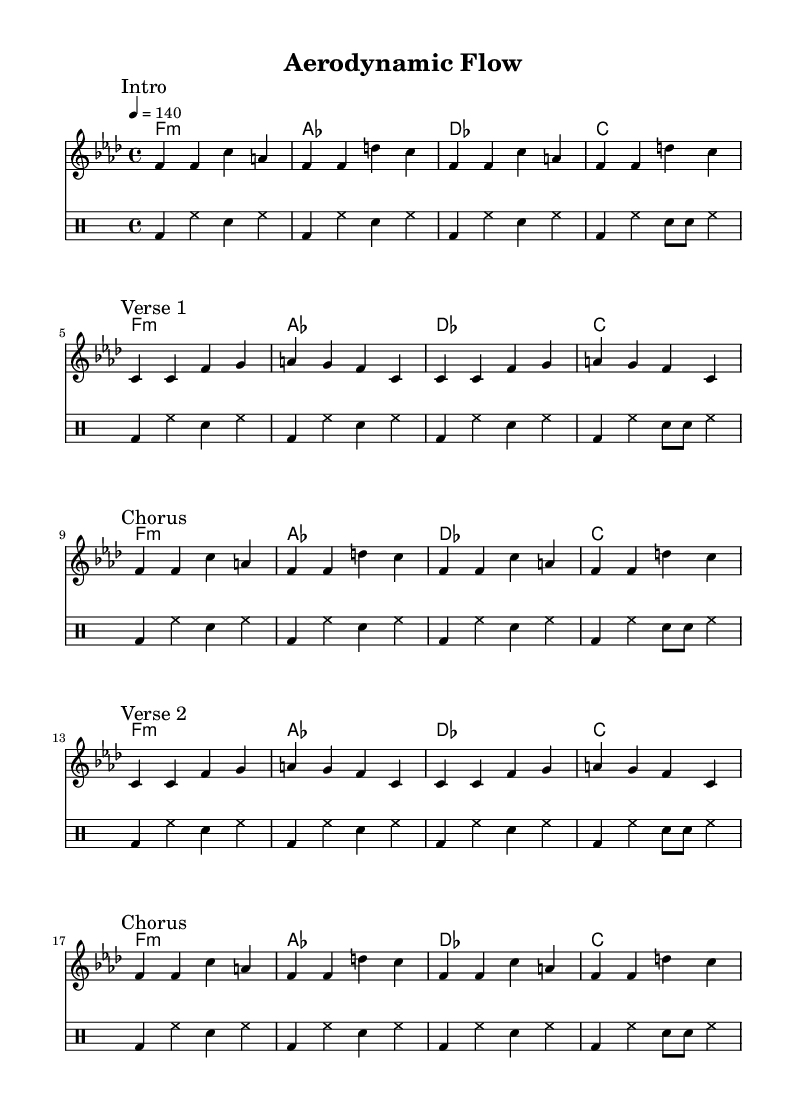What is the key signature of this music? The key signature is indicated at the beginning of the piece. It shows that there are four flats in the key signature, which corresponds to F minor.
Answer: F minor What is the time signature of this piece? The time signature is found at the beginning of the sheet music, which indicates the number of beats in each measure. It shows that there are four beats per measure, represented as 4/4.
Answer: 4/4 What tempo is indicated for the piece? The tempo marking indicates the speed of the piece. Here, it is set at 140 beats per minute, which is shown as "4 = 140."
Answer: 140 How many times is the main hook repeated in the melody? To find the repetition of the main hook, look for the sections labeled in the music. The main hook appears twice before the first break and twice again before the first chorus, making a total of four repetitions.
Answer: 4 What instrument is indicated for the chord names? The score contains a section labeled "ChordNames." This indicates that the chords are played on a harmonic instrument, typically used for accompaniment.
Answer: ChordNames Why is the verse pattern significant in this rap track? The verse pattern establishes a lyrical basis vital to rap. Analyzing the repeated arrangements in the melody highlights the song's rhythm and flow, showing how they support the delivery of lyrics. The repetitive structure in verse patterns is essential for creating a dynamic rap experience, maintaining listener engagement.
Answer: Verses How does the drum part contribute to the energy of the rap track? The drum part is written in a distinct rhythmic pattern that features bass drums, hi-hats, and snare drums. Analyzing the consistent beat and syncopation creates a driving rhythm that elevates the energy, supporting the high-speed racing theme effectively in the context of the rap.
Answer: High-energy 